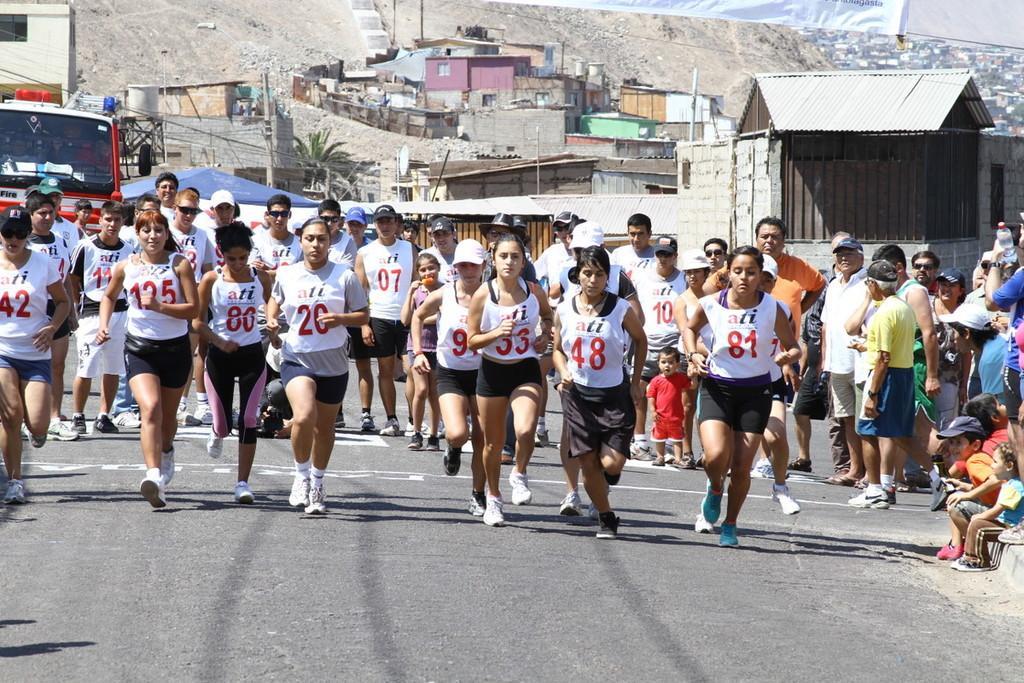Can you describe this image briefly? In this image we can see a group of people wearing dress are standing on the ground. On the right side of the image we can see a person wearing the cap with the yellow t shirt. In the background, we can see a group of buildings, a vehicle parked on the road. 